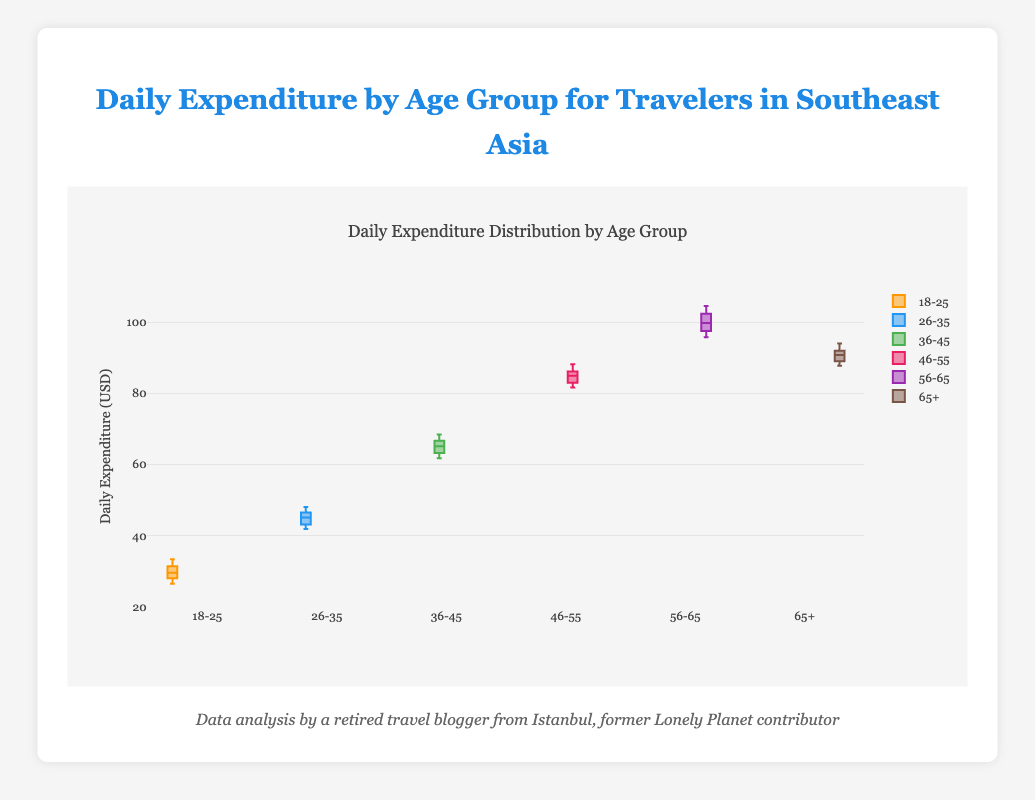What is the title of the plot? The title of the plot is displayed at the top of the figure. It reads "Daily Expenditure Distribution by Age Group".
Answer: Daily Expenditure Distribution by Age Group Which age group has the highest median daily expenditure? The median is shown by the line inside each box. The 56-65 age group has the highest median, as their line is the highest on the y-axis.
Answer: 56-65 What range does the y-axis cover? The y-axis starts at 20 and goes up to 110, as indicated by the tick marks along the axis.
Answer: 20 to 110 How does the median daily expenditure of the 26-35 age group compare to the 18-25 age group? The median line for the 26-35 age group is higher than that of the 18-25 age group, indicating a higher median daily expenditure.
Answer: Higher What is the interquartile range (IQR) of the 36-45 age group? The IQR is the range between the first quartile (bottom of the box) and the third quartile (top of the box). For the 36-45 age group, it spans from approximately 63 to 66, giving an IQR of 3.
Answer: 3 Which age group shows the greatest variability in daily expenditure? The length of the boxes and the distance between the whiskers indicate variability. The age group 56-65, with the longest box and widest whiskers, shows the greatest variability.
Answer: 56-65 Are there any outliers in the data? If so, in which groups? Outliers are typically shown as dots outside the whiskers. From the figure, there are no outliers present in any of the age groups.
Answer: No What color represents the 46-55 age group? Each age group is represented by a different color. The 46-55 age group is represented by pink color.
Answer: Pink How does the upper whisker of the 65+ age group compare to the lower whisker of the 56-65 age group? The upper whisker of the 65+ age group is slightly below the lower whisker of the 56-65 age group, indicating lower maximum spending for the older group than the minimum of the 56-65 group.
Answer: Lower Which age group has the smallest interquartile range (IQR)? Comparing the boxes for each group, the 18-25 age group has the smallest interquartile range as its box is the narrowest.
Answer: 18-25 